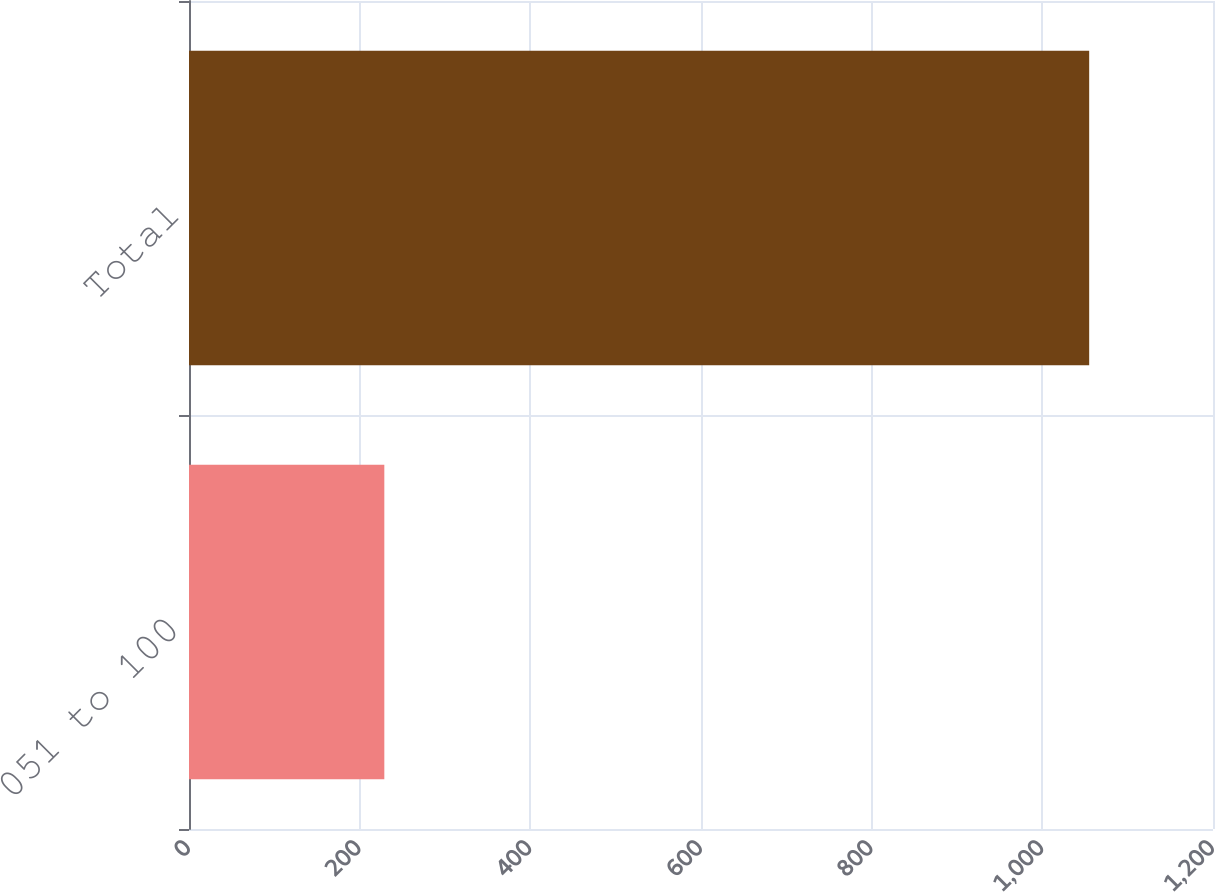<chart> <loc_0><loc_0><loc_500><loc_500><bar_chart><fcel>051 to 100<fcel>Total<nl><fcel>228.9<fcel>1054.9<nl></chart> 